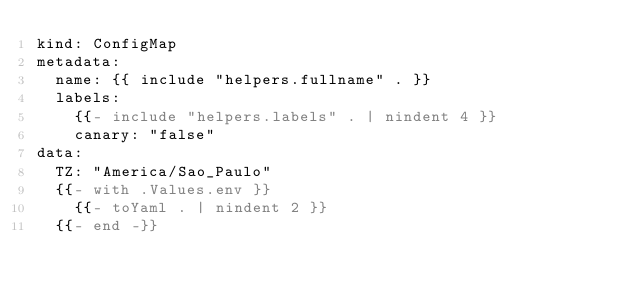<code> <loc_0><loc_0><loc_500><loc_500><_YAML_>kind: ConfigMap
metadata:
  name: {{ include "helpers.fullname" . }}
  labels:
    {{- include "helpers.labels" . | nindent 4 }}
    canary: "false"
data:
  TZ: "America/Sao_Paulo"
  {{- with .Values.env }}
    {{- toYaml . | nindent 2 }}
  {{- end -}}</code> 